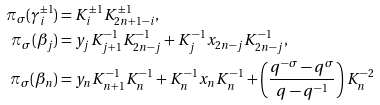<formula> <loc_0><loc_0><loc_500><loc_500>\pi _ { \sigma } ( \gamma _ { i } ^ { \pm 1 } ) & = K _ { i } ^ { \pm 1 } K _ { 2 n + 1 - i } ^ { \pm 1 } , \\ \pi _ { \sigma } ( \beta _ { j } ) & = y _ { j } K _ { j + 1 } ^ { - 1 } K _ { 2 n - j } ^ { - 1 } + K _ { j } ^ { - 1 } x _ { 2 n - j } K _ { 2 n - j } ^ { - 1 } , \\ \pi _ { \sigma } ( \beta _ { n } ) & = y _ { n } K _ { n + 1 } ^ { - 1 } K _ { n } ^ { - 1 } + K _ { n } ^ { - 1 } x _ { n } K _ { n } ^ { - 1 } + \left ( \frac { q ^ { - \sigma } - q ^ { \sigma } } { q - q ^ { - 1 } } \right ) K _ { n } ^ { - 2 }</formula> 